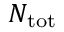<formula> <loc_0><loc_0><loc_500><loc_500>N _ { t o t }</formula> 